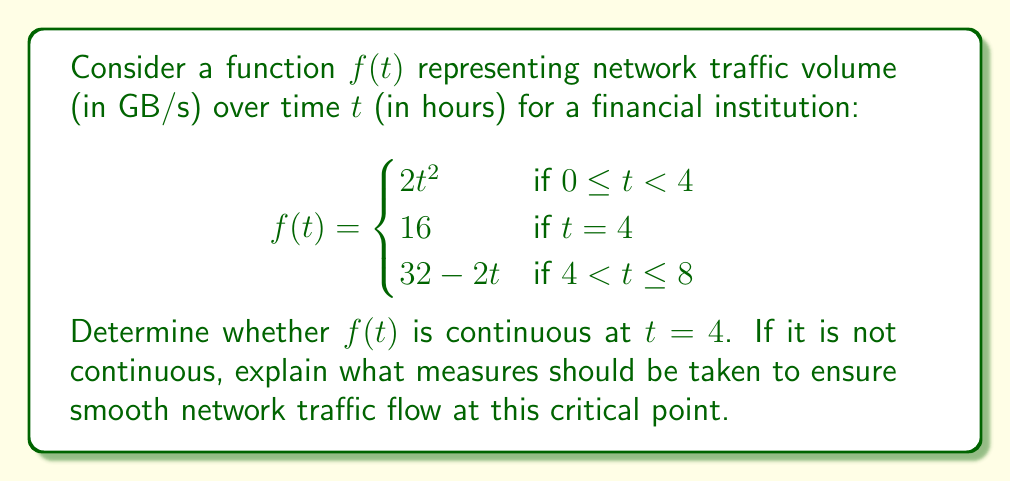Teach me how to tackle this problem. To determine if $f(t)$ is continuous at $t = 4$, we need to check three conditions:

1. $f(t)$ is defined at $t = 4$
2. $\lim_{t \to 4^-} f(t)$ exists
3. $\lim_{t \to 4^+} f(t)$ exists
4. $\lim_{t \to 4^-} f(t) = \lim_{t \to 4^+} f(t) = f(4)$

Let's check each condition:

1. $f(4)$ is defined and equals 16.

2. $\lim_{t \to 4^-} f(t) = \lim_{t \to 4^-} 2t^2 = 2(4)^2 = 32$

3. $\lim_{t \to 4^+} f(t) = \lim_{t \to 4^+} (32 - 2t) = 32 - 2(4) = 24$

4. Comparing the results:
   $\lim_{t \to 4^-} f(t) = 32$
   $\lim_{t \to 4^+} f(t) = 24$
   $f(4) = 16$

Since these three values are not equal, $f(t)$ is not continuous at $t = 4$.

To ensure smooth network traffic flow at this critical point, the following measures should be taken:

1. Implement a gradual transition between the different traffic patterns around $t = 4$.
2. Increase network capacity to handle the peak traffic at $\lim_{t \to 4^-} f(t) = 32$ GB/s.
3. Use load balancing techniques to distribute traffic more evenly across the time period.
4. Set up alerts for when traffic approaches the discontinuity point to proactively manage potential issues.
5. Consider redefining $f(4)$ to be the average of the left and right limits: $f(4) = \frac{32 + 24}{2} = 28$ GB/s, and adjust the surrounding intervals accordingly to create a continuous function.
Answer: $f(t)$ is not continuous at $t = 4$. Measures should be taken to smooth the transition between traffic patterns, increase network capacity, implement load balancing, set up alerts, and potentially redefine the function to ensure continuity. 